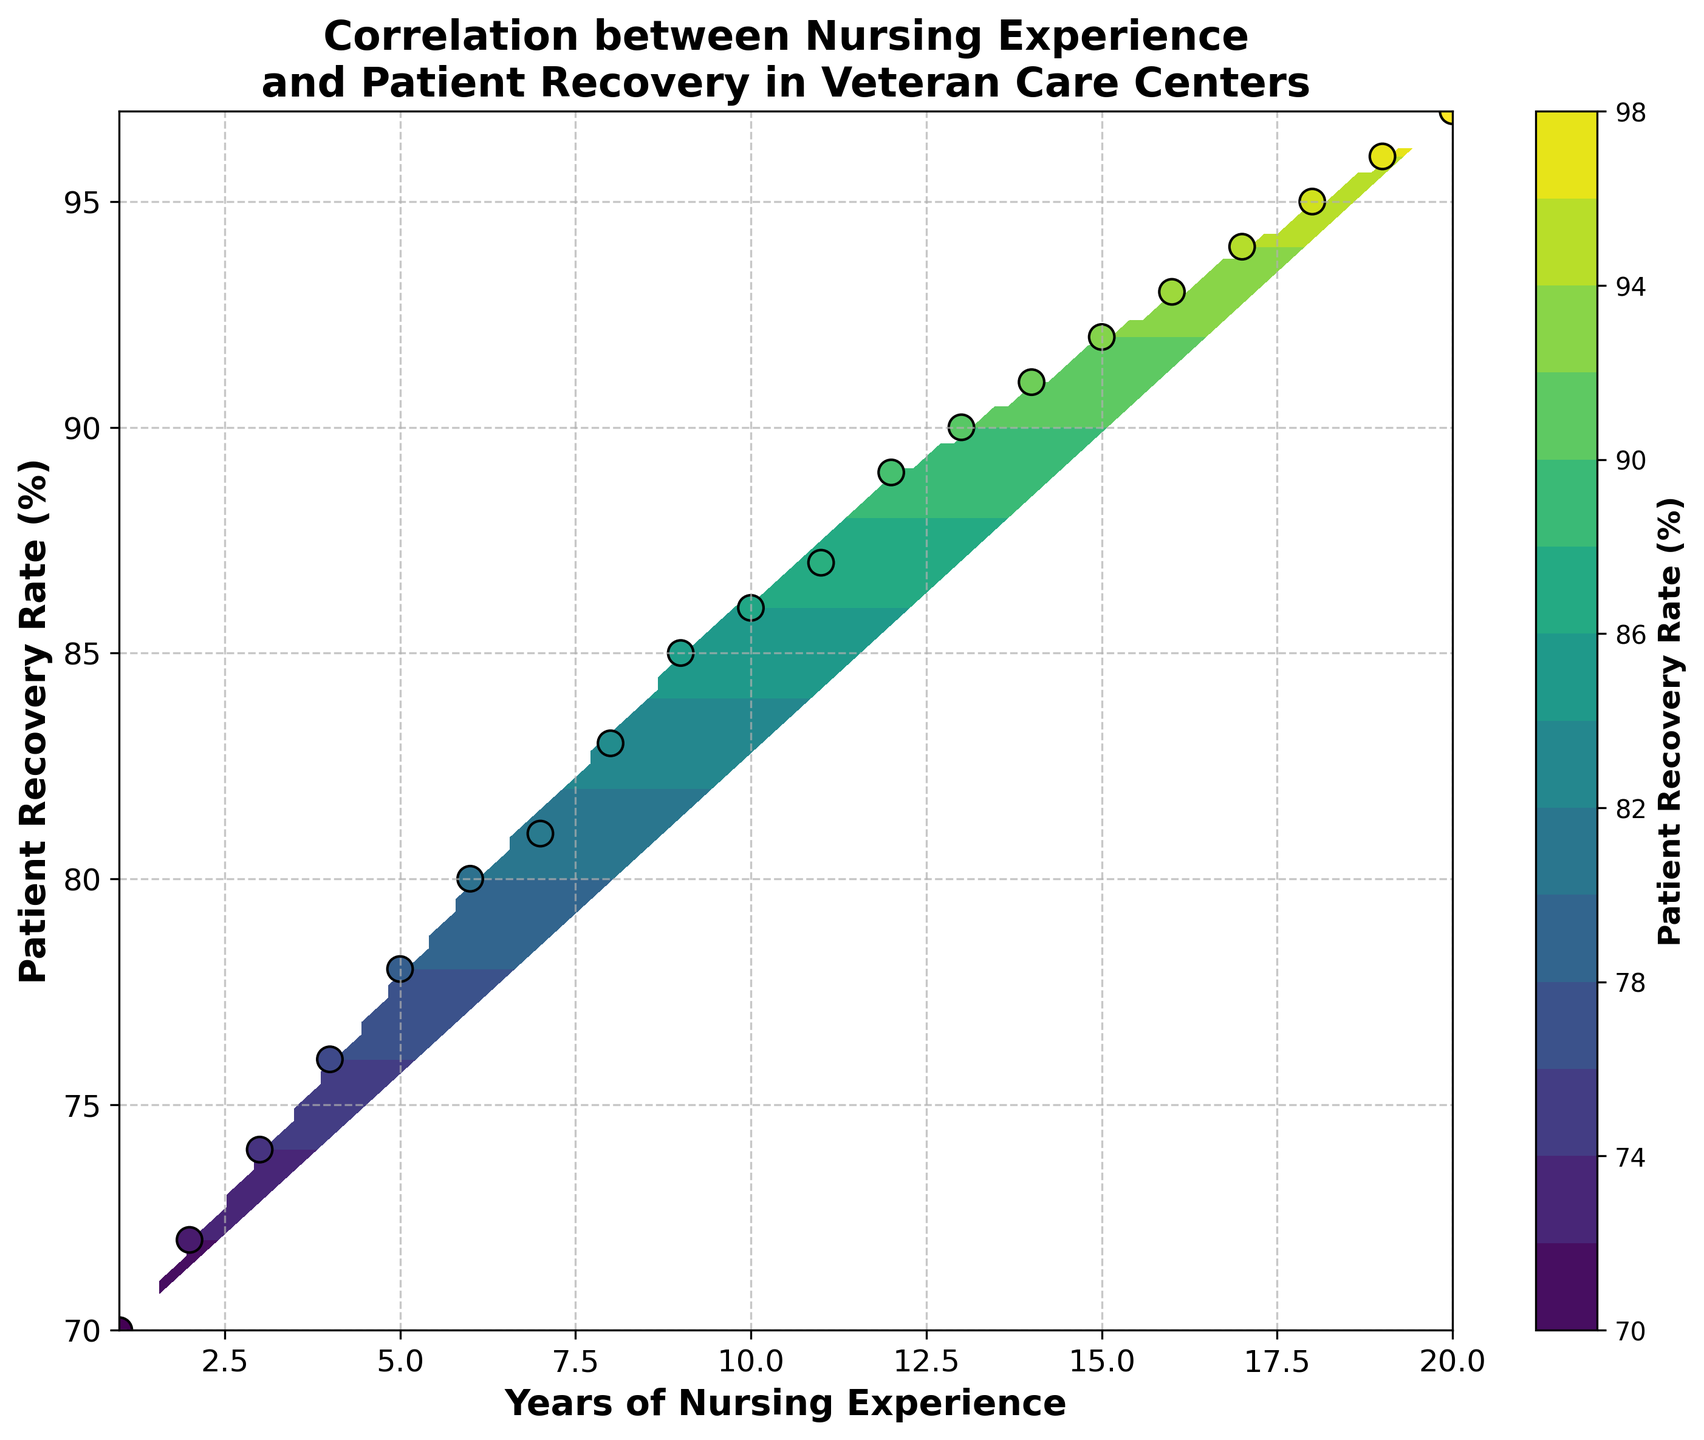What's the title of the plot? The title is usually located at the top of the plot. It summarizes the focus of the plot.
Answer: Correlation between Nursing Experience and Patient Recovery in Veteran Care Centers What are the labels on the x- and y-axes? Axis labels are typically found next to the respective axes and provide information on what each axis represents.
Answer: Years of Nursing Experience (x-axis), Patient Recovery Rate (%) (y-axis) How does the patient recovery rate change with an increase in years of nursing experience? By observing the contour lines and the distribution of scatter points, we can see the general trend.
Answer: It increases What's the color range in the colorbar for the patient recovery rate? The colorbar indicates the range of values represented by different colors.
Answer: It ranges from 70% to 97% How many data points are there in the scatter plot? Count the number of individual scatter points in the plot.
Answer: 20 What does the innermost contour line represent about the patient recovery rate? The innermost contour line surrounds the area with the highest recovery rate value.
Answer: Near 97% Is there a point where the nursing experience has the least impact on patient recovery? Identify the region where contour lines are widely spaced, indicating little change in recovery rate relative to changes in nursing experience.
Answer: Between 1-2 and 12-14 years Are there any steep changes in patient recovery rate depicted in the contour plot? Where? Steep changes in the recovery rate are represented by closely spaced contour lines.
Answer: Yes, between 10 to 15 years Which years of nursing experience lead to a recovery rate of around 90%? Examine the contour lines near the 90% level and check where they intersect the nursing experience axis.
Answer: 13 to 14 years What can you infer about the correlation between nursing experience and patient recovery rate from the plot? The explanation should consider the overall trend, contour spacings, and scatter plot distribution.
Answer: A positive correlation where more experience generally leads to higher recovery rates 